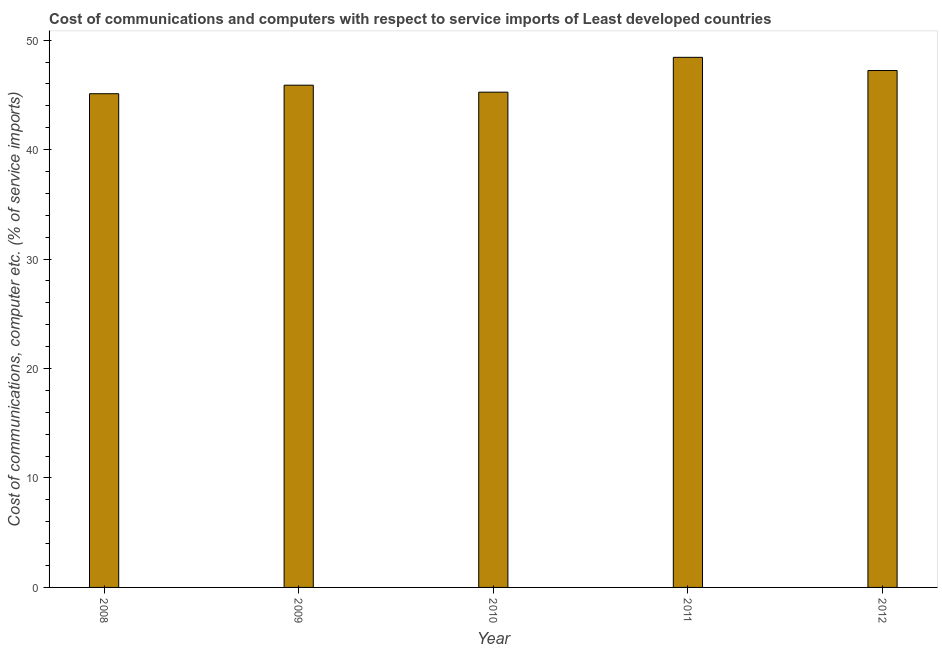Does the graph contain any zero values?
Your response must be concise. No. What is the title of the graph?
Provide a short and direct response. Cost of communications and computers with respect to service imports of Least developed countries. What is the label or title of the Y-axis?
Keep it short and to the point. Cost of communications, computer etc. (% of service imports). What is the cost of communications and computer in 2011?
Your answer should be very brief. 48.43. Across all years, what is the maximum cost of communications and computer?
Provide a succinct answer. 48.43. Across all years, what is the minimum cost of communications and computer?
Offer a terse response. 45.11. In which year was the cost of communications and computer maximum?
Provide a short and direct response. 2011. What is the sum of the cost of communications and computer?
Your answer should be very brief. 231.9. What is the difference between the cost of communications and computer in 2009 and 2012?
Provide a succinct answer. -1.34. What is the average cost of communications and computer per year?
Your answer should be very brief. 46.38. What is the median cost of communications and computer?
Offer a terse response. 45.89. Do a majority of the years between 2008 and 2011 (inclusive) have cost of communications and computer greater than 20 %?
Make the answer very short. Yes. What is the ratio of the cost of communications and computer in 2008 to that in 2011?
Offer a terse response. 0.93. Is the difference between the cost of communications and computer in 2008 and 2010 greater than the difference between any two years?
Provide a short and direct response. No. What is the difference between the highest and the second highest cost of communications and computer?
Provide a short and direct response. 1.21. What is the difference between the highest and the lowest cost of communications and computer?
Ensure brevity in your answer.  3.32. Are all the bars in the graph horizontal?
Your answer should be very brief. No. How many years are there in the graph?
Ensure brevity in your answer.  5. What is the difference between two consecutive major ticks on the Y-axis?
Ensure brevity in your answer.  10. Are the values on the major ticks of Y-axis written in scientific E-notation?
Your answer should be compact. No. What is the Cost of communications, computer etc. (% of service imports) in 2008?
Make the answer very short. 45.11. What is the Cost of communications, computer etc. (% of service imports) of 2009?
Provide a succinct answer. 45.89. What is the Cost of communications, computer etc. (% of service imports) in 2010?
Give a very brief answer. 45.25. What is the Cost of communications, computer etc. (% of service imports) of 2011?
Provide a succinct answer. 48.43. What is the Cost of communications, computer etc. (% of service imports) in 2012?
Give a very brief answer. 47.23. What is the difference between the Cost of communications, computer etc. (% of service imports) in 2008 and 2009?
Offer a terse response. -0.78. What is the difference between the Cost of communications, computer etc. (% of service imports) in 2008 and 2010?
Provide a short and direct response. -0.14. What is the difference between the Cost of communications, computer etc. (% of service imports) in 2008 and 2011?
Offer a very short reply. -3.32. What is the difference between the Cost of communications, computer etc. (% of service imports) in 2008 and 2012?
Provide a short and direct response. -2.12. What is the difference between the Cost of communications, computer etc. (% of service imports) in 2009 and 2010?
Offer a very short reply. 0.64. What is the difference between the Cost of communications, computer etc. (% of service imports) in 2009 and 2011?
Give a very brief answer. -2.55. What is the difference between the Cost of communications, computer etc. (% of service imports) in 2009 and 2012?
Provide a succinct answer. -1.34. What is the difference between the Cost of communications, computer etc. (% of service imports) in 2010 and 2011?
Offer a terse response. -3.18. What is the difference between the Cost of communications, computer etc. (% of service imports) in 2010 and 2012?
Give a very brief answer. -1.98. What is the difference between the Cost of communications, computer etc. (% of service imports) in 2011 and 2012?
Give a very brief answer. 1.21. What is the ratio of the Cost of communications, computer etc. (% of service imports) in 2008 to that in 2010?
Your response must be concise. 1. What is the ratio of the Cost of communications, computer etc. (% of service imports) in 2008 to that in 2012?
Give a very brief answer. 0.95. What is the ratio of the Cost of communications, computer etc. (% of service imports) in 2009 to that in 2011?
Give a very brief answer. 0.95. What is the ratio of the Cost of communications, computer etc. (% of service imports) in 2010 to that in 2011?
Make the answer very short. 0.93. What is the ratio of the Cost of communications, computer etc. (% of service imports) in 2010 to that in 2012?
Provide a succinct answer. 0.96. 